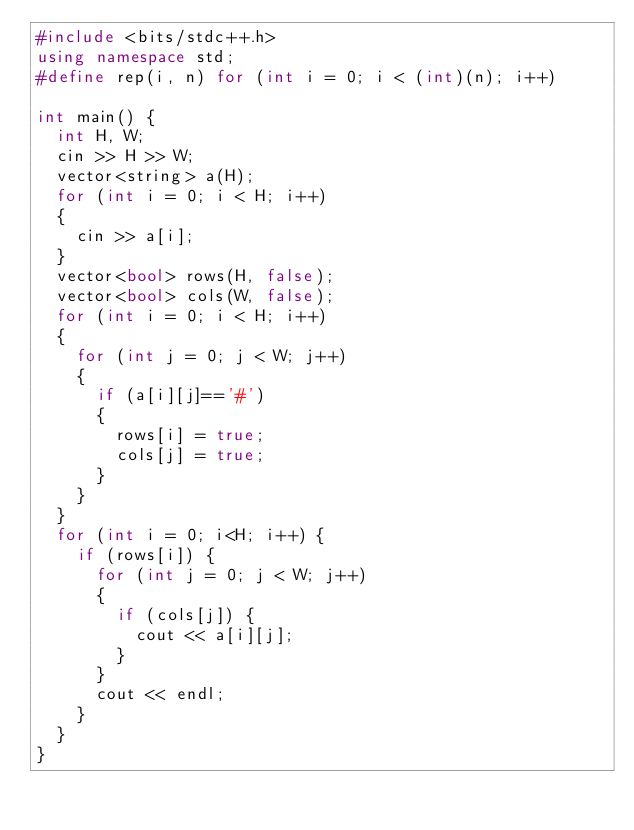<code> <loc_0><loc_0><loc_500><loc_500><_C++_>#include <bits/stdc++.h>
using namespace std;
#define rep(i, n) for (int i = 0; i < (int)(n); i++)

int main() {
  int H, W;
  cin >> H >> W;
  vector<string> a(H);
  for (int i = 0; i < H; i++)
  {
    cin >> a[i];
  }
  vector<bool> rows(H, false);
  vector<bool> cols(W, false);
  for (int i = 0; i < H; i++)
  {
    for (int j = 0; j < W; j++)
    {
      if (a[i][j]=='#')
      {
        rows[i] = true;
        cols[j] = true;
      }
    }
  }
  for (int i = 0; i<H; i++) {
    if (rows[i]) {
      for (int j = 0; j < W; j++)
      {
        if (cols[j]) {
          cout << a[i][j];
        }
      }
      cout << endl;
    }
  }
}</code> 